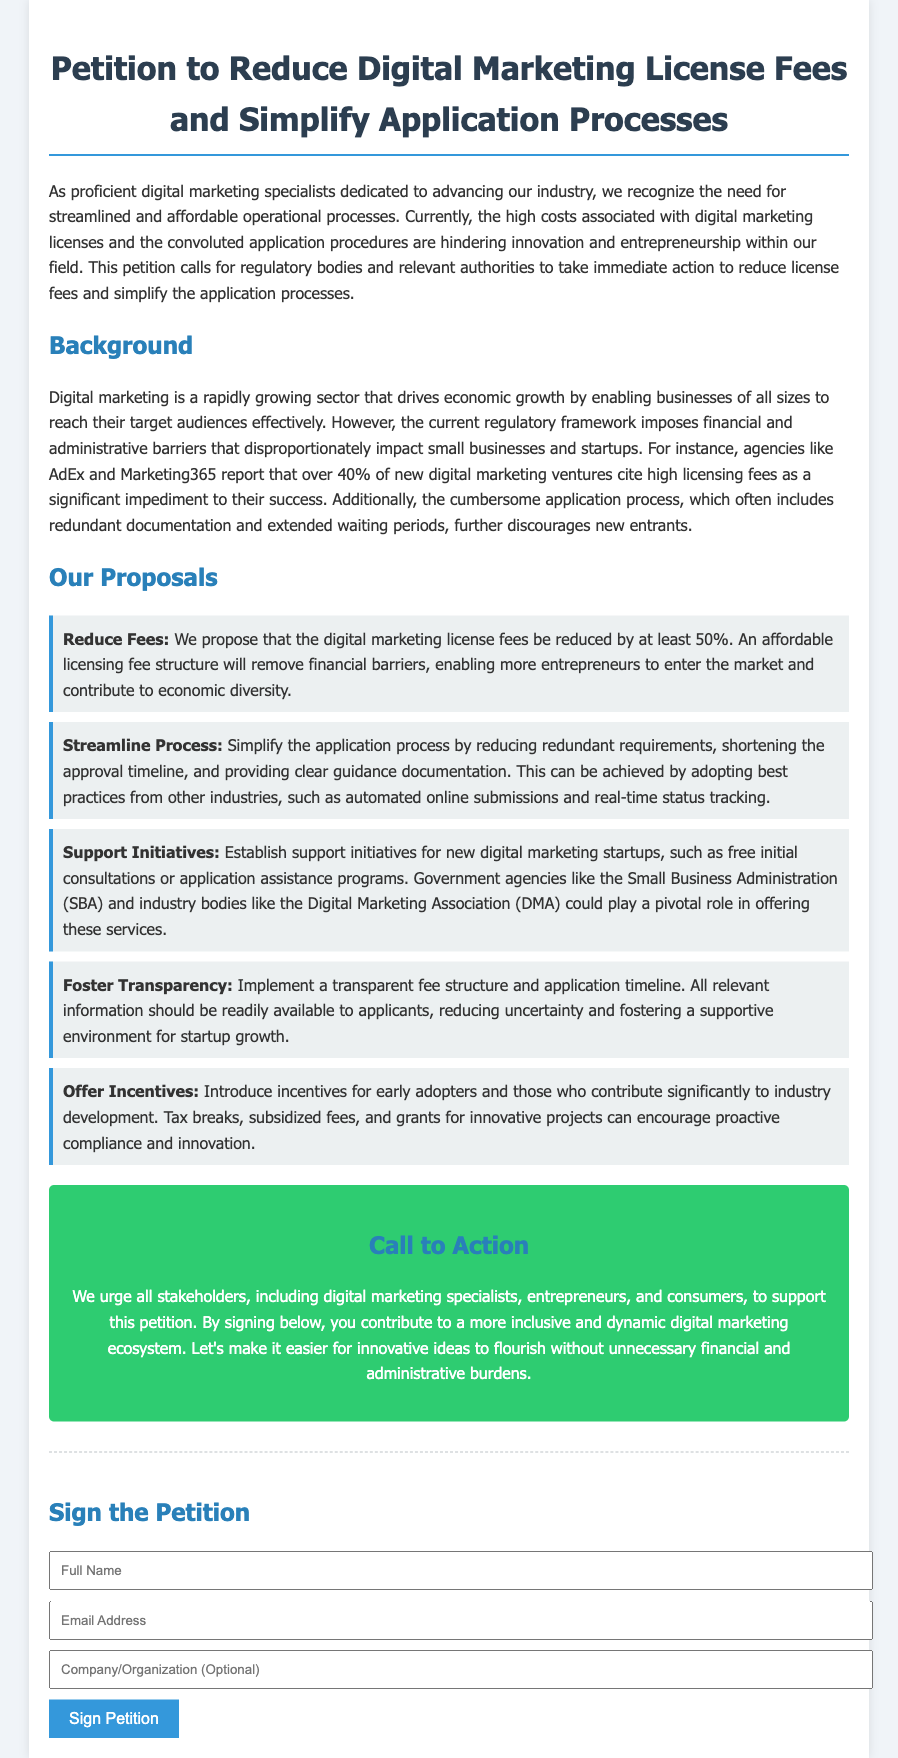What is the title of the petition? The title of the petition is provided at the top of the document, which states the main purpose clearly.
Answer: Petition to Reduce Digital Marketing License Fees and Simplify Application Processes What percentage of new digital marketing ventures cite high licensing fees as a significant impediment? The document mentions a specific statistic regarding the impact of licensing fees on new ventures.
Answer: 40% What is one of the proposals made in the document? The document lists various proposals aimed at improving the digital marketing landscape.
Answer: Reduce Fees Which government agency is mentioned as a potential supporter for new digital marketing startups? The document references specific organizations that could assist with support initiatives for startups.
Answer: Small Business Administration (SBA) What is the color of the call to action section? The document describes the styling choices for different sections, specifically noting the color of the call to action.
Answer: Green How many proposals are listed in the document? The document specifies the number of distinct proposals that address the main issues.
Answer: Five What is the purpose of the signature section? The signature section's intent is to encourage support for the petition by gathering names and contact information.
Answer: To sign the petition What does the petition urge stakeholders to do? The document calls upon various stakeholders to take specific action regarding the petition.
Answer: Support this petition 